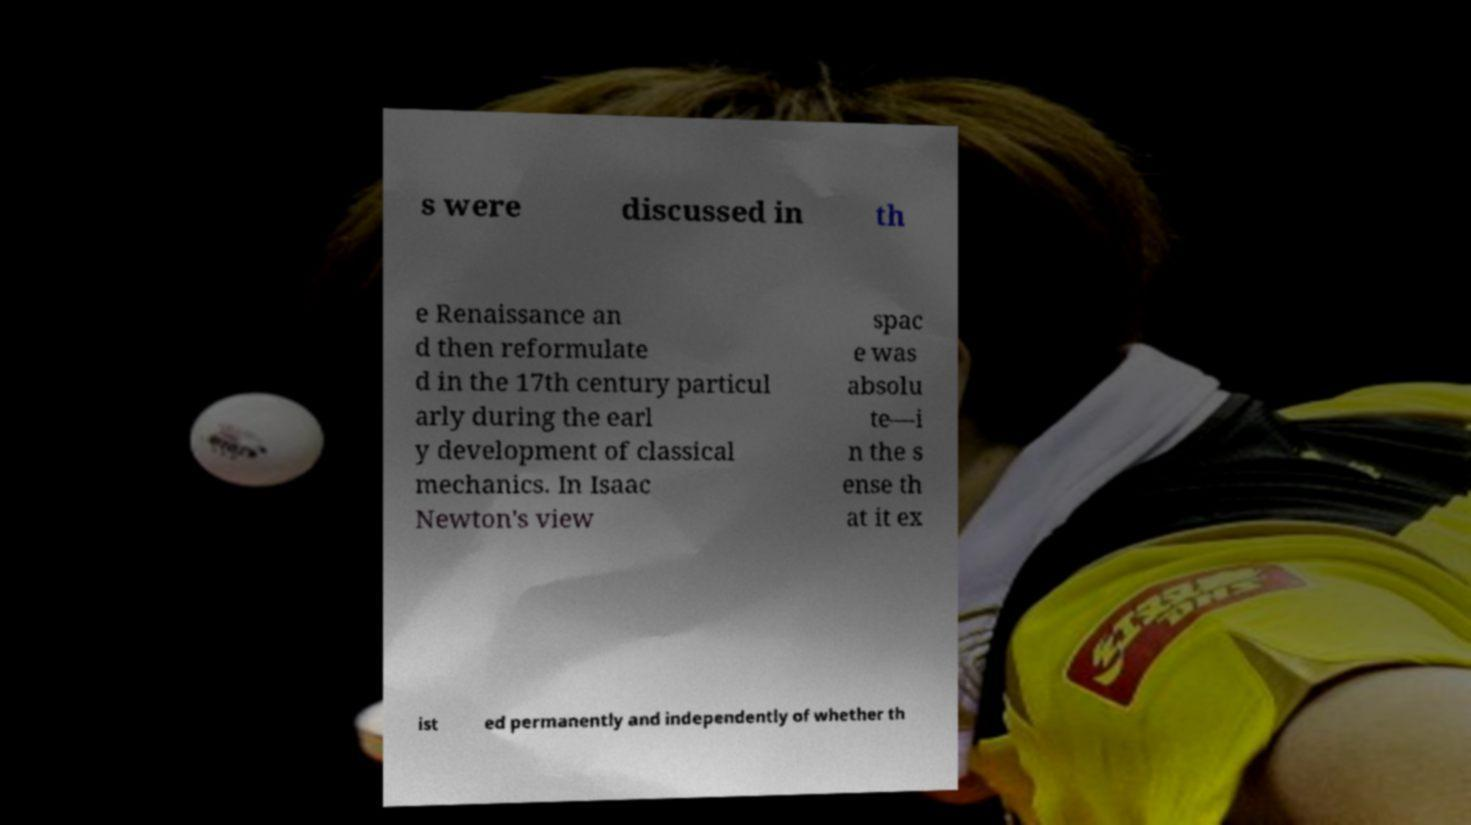There's text embedded in this image that I need extracted. Can you transcribe it verbatim? s were discussed in th e Renaissance an d then reformulate d in the 17th century particul arly during the earl y development of classical mechanics. In Isaac Newton's view spac e was absolu te—i n the s ense th at it ex ist ed permanently and independently of whether th 